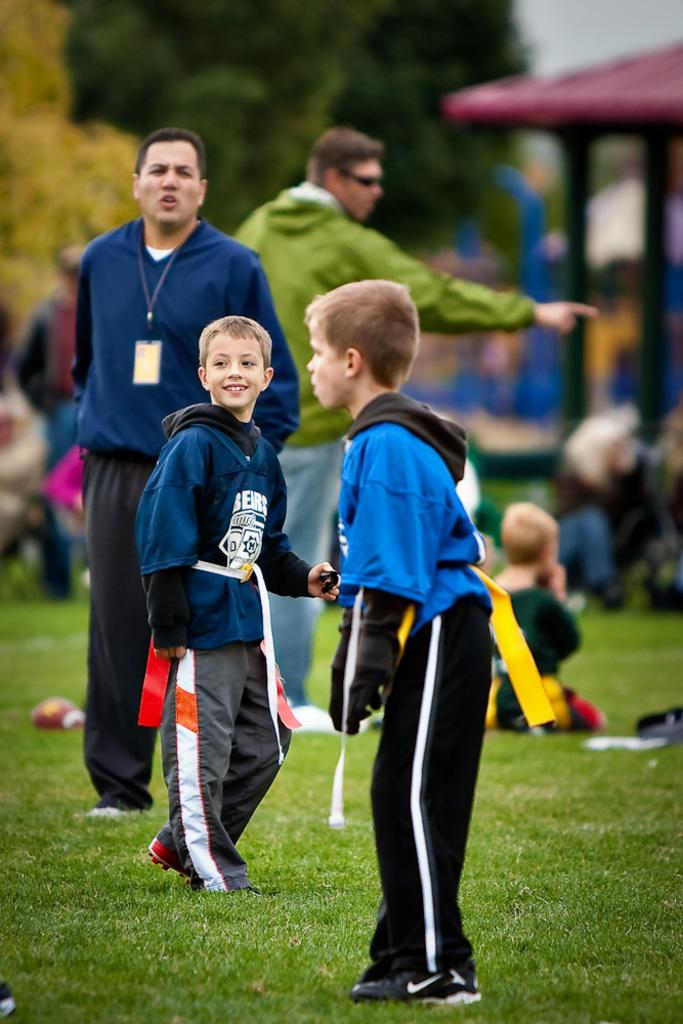How many people are in the image? There is a group of people in the image, but the exact number is not specified. What are the people in the image doing? Some people are sitting, while others are standing. Where are the people located in the image? The people are on the ground. What can be seen in the background of the image? There are trees and a shed in the background of the image. How would you describe the background of the image? The background appears blurry. How many oranges are being held by the people in the image? There is no mention of oranges in the image, so it is impossible to determine how many are being held. What effect does the finger have on the people in the image? There is no mention of a finger in the image, so it is impossible to determine any effect it might have. 